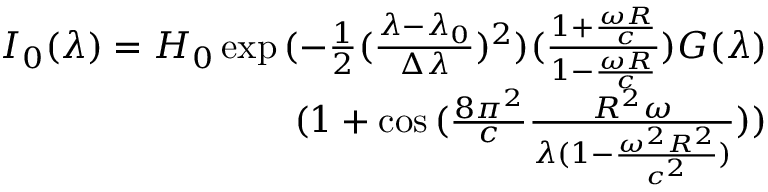<formula> <loc_0><loc_0><loc_500><loc_500>\begin{array} { r } { I _ { 0 } ( \lambda ) = H _ { 0 } \exp { ( - \frac { 1 } { 2 } ( \frac { \lambda - \lambda _ { 0 } } { \Delta \lambda } ) ^ { 2 } ) ( \frac { 1 + \frac { \omega R } { c } } { 1 - \frac { \omega R } { c } } ) } G ( \lambda ) } \\ { ( 1 + \cos { ( \frac { 8 \pi ^ { 2 } } { c } \frac { R ^ { 2 } \omega } { \lambda ( 1 - \frac { \omega ^ { 2 } R ^ { 2 } } { c ^ { 2 } } ) } ) } ) } \end{array}</formula> 